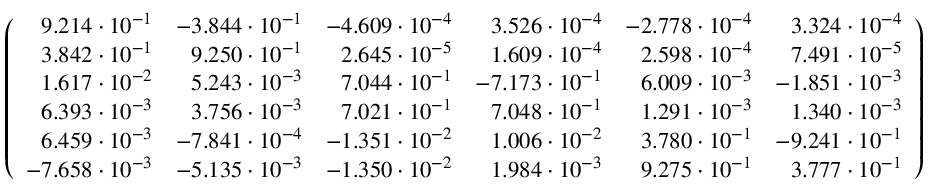<formula> <loc_0><loc_0><loc_500><loc_500>\left ( \begin{array} { r r r r r r } { 9 . 2 1 4 \cdot 1 0 ^ { - 1 } } & { - 3 . 8 4 4 \cdot 1 0 ^ { - 1 } } & { - 4 . 6 0 9 \cdot 1 0 ^ { - 4 } } & { 3 . 5 2 6 \cdot 1 0 ^ { - 4 } } & { - 2 . 7 7 8 \cdot 1 0 ^ { - 4 } } & { 3 . 3 2 4 \cdot 1 0 ^ { - 4 } } \\ { 3 . 8 4 2 \cdot 1 0 ^ { - 1 } } & { 9 . 2 5 0 \cdot 1 0 ^ { - 1 } } & { 2 . 6 4 5 \cdot 1 0 ^ { - 5 } } & { 1 . 6 0 9 \cdot 1 0 ^ { - 4 } } & { 2 . 5 9 8 \cdot 1 0 ^ { - 4 } } & { 7 . 4 9 1 \cdot 1 0 ^ { - 5 } } \\ { 1 . 6 1 7 \cdot 1 0 ^ { - 2 } } & { 5 . 2 4 3 \cdot 1 0 ^ { - 3 } } & { 7 . 0 4 4 \cdot 1 0 ^ { - 1 } } & { - 7 . 1 7 3 \cdot 1 0 ^ { - 1 } } & { 6 . 0 0 9 \cdot 1 0 ^ { - 3 } } & { - 1 . 8 5 1 \cdot 1 0 ^ { - 3 } } \\ { 6 . 3 9 3 \cdot 1 0 ^ { - 3 } } & { 3 . 7 5 6 \cdot 1 0 ^ { - 3 } } & { 7 . 0 2 1 \cdot 1 0 ^ { - 1 } } & { 7 . 0 4 8 \cdot 1 0 ^ { - 1 } } & { 1 . 2 9 1 \cdot 1 0 ^ { - 3 } } & { 1 . 3 4 0 \cdot 1 0 ^ { - 3 } } \\ { 6 . 4 5 9 \cdot 1 0 ^ { - 3 } } & { - 7 . 8 4 1 \cdot 1 0 ^ { - 4 } } & { - 1 . 3 5 1 \cdot 1 0 ^ { - 2 } } & { 1 . 0 0 6 \cdot 1 0 ^ { - 2 } } & { 3 . 7 8 0 \cdot 1 0 ^ { - 1 } } & { - 9 . 2 4 1 \cdot 1 0 ^ { - 1 } } \\ { - 7 . 6 5 8 \cdot 1 0 ^ { - 3 } } & { - 5 . 1 3 5 \cdot 1 0 ^ { - 3 } } & { - 1 . 3 5 0 \cdot 1 0 ^ { - 2 } } & { 1 . 9 8 4 \cdot 1 0 ^ { - 3 } } & { 9 . 2 7 5 \cdot 1 0 ^ { - 1 } } & { 3 . 7 7 7 \cdot 1 0 ^ { - 1 } } \end{array} \right )</formula> 